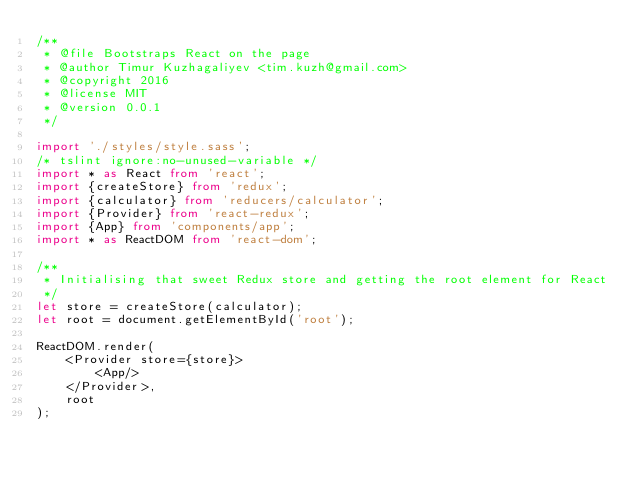Convert code to text. <code><loc_0><loc_0><loc_500><loc_500><_TypeScript_>/**
 * @file Bootstraps React on the page
 * @author Timur Kuzhagaliyev <tim.kuzh@gmail.com>
 * @copyright 2016
 * @license MIT
 * @version 0.0.1
 */

import './styles/style.sass';
/* tslint ignore:no-unused-variable */
import * as React from 'react';
import {createStore} from 'redux';
import {calculator} from 'reducers/calculator';
import {Provider} from 'react-redux';
import {App} from 'components/app';
import * as ReactDOM from 'react-dom';

/**
 * Initialising that sweet Redux store and getting the root element for React
 */
let store = createStore(calculator);
let root = document.getElementById('root');

ReactDOM.render(
    <Provider store={store}>
        <App/>
    </Provider>,
    root
);
</code> 